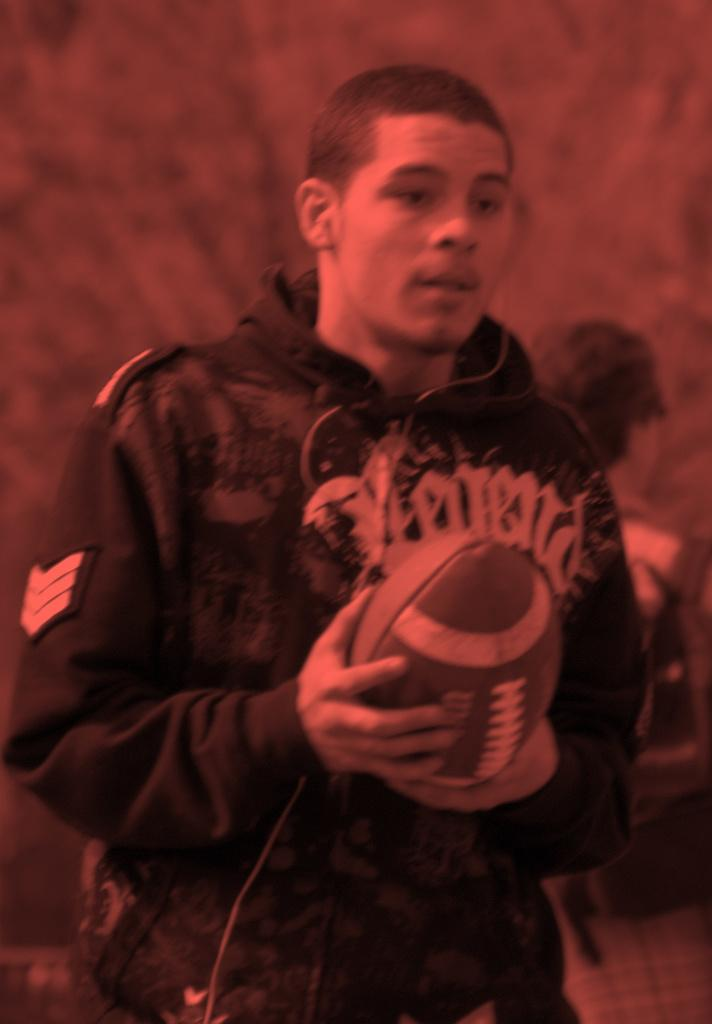What is the main subject of the picture? The main subject of the picture is a person. What is the person holding in the picture? The person is holding a rugby ball. What type of rhythm can be heard from the person in the image? There is no indication of any rhythm or sound in the image, as it only shows a person holding a rugby ball. 